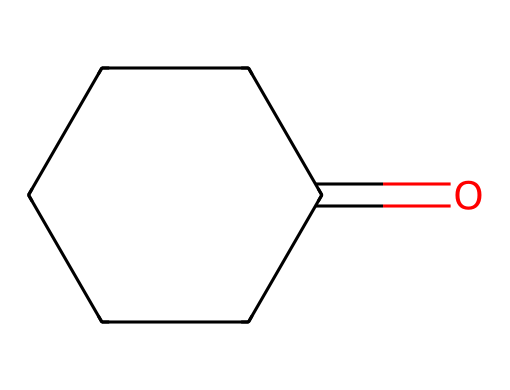What is the molecular formula of cyclohexanone? The molecular formula can be derived from the structure, counting the carbon (C) and oxygen (O) atoms. There are six carbon atoms and one oxygen atom in the structure represented by the SMILES notation.
Answer: C6H10O How many carbon atoms are present in cyclohexanone? By analyzing the chemical structure, we see that there are six carbon atoms arranged in a ring.
Answer: 6 What type of functional group is present in cyclohexanone? The presence of a carbonyl group (C=O) in the structure indicates that cyclohexanone contains a ketone functional group.
Answer: ketone What is the saturation of the cyclohexanone molecule? The molecule is saturated because all carbon atoms are single-bonded except for the one with the carbonyl group, which does not introduce double bond character to any other carbon carbon bonds in the ring.
Answer: saturated How many hydrogen atoms are there in cyclohexanone? To determine the number of hydrogen atoms, we can use the general formula for saturated hydrocarbons (CnH2n+2). With 6 carbon atoms, applying n=6 yields 14 hydrogens, but since the ring structure and one carbonyl reduces this by 4, there are 10 hydrogen atoms overall.
Answer: 10 What role does cyclohexanone play in nylon production? Cyclohexanone serves as an important precursor in the synthesis of nylon, specifically in the production of intermediates like caprolactam.
Answer: precursor Which property of cyclohexanone contributes to its use in vehicle upholstery? The stability and chemical properties of cyclohexanone make it a suitable material for synthesis processes, contributing to the durability of resulting nylon fabrics used in vehicle upholstery.
Answer: stability 